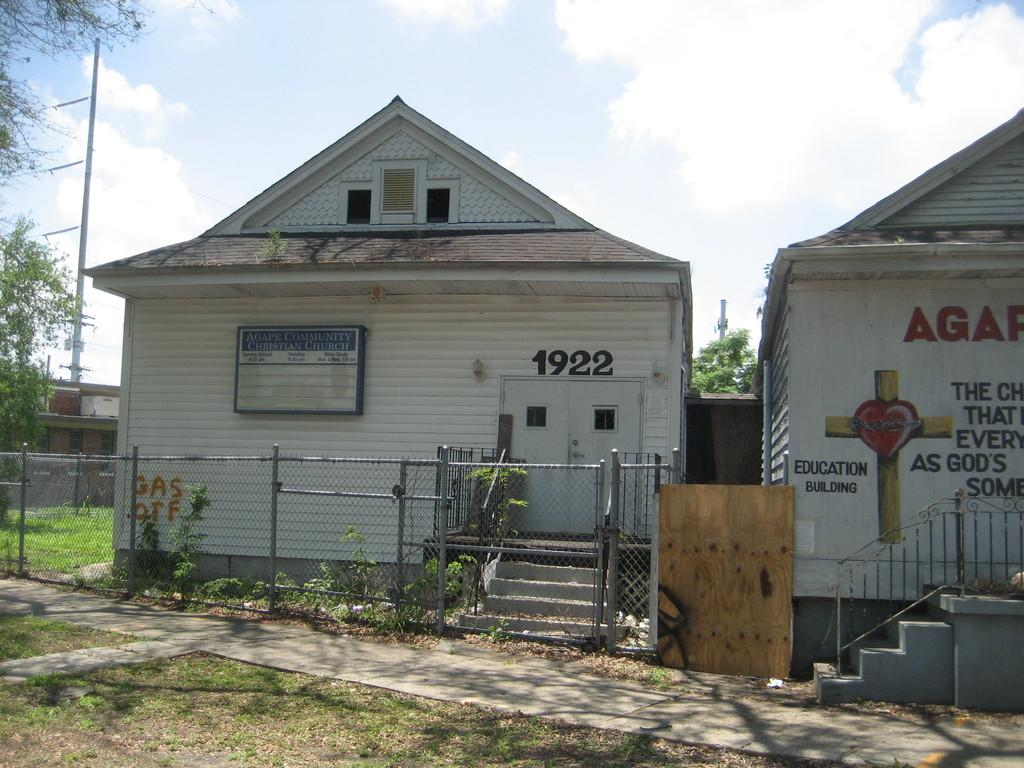How many white buildings are present in the image? There are two white buildings in the image. What is located in front of the buildings? There is a railing in front of the buildings. What type of vegetation can be seen in the image? There are green trees in the image. What other structure is visible in the image? There is an electric pole in the image. What is the color of the sky in the image? The sky is white in color. What type of fiction is being advertised on the hall in the image? There is no hall or advertisement present in the image. 